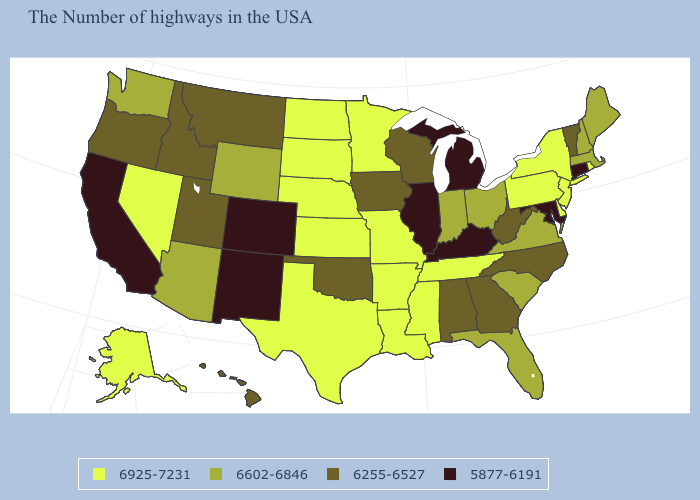What is the value of Delaware?
Be succinct. 6925-7231. Among the states that border Missouri , does Arkansas have the highest value?
Answer briefly. Yes. Which states have the highest value in the USA?
Quick response, please. Rhode Island, New York, New Jersey, Delaware, Pennsylvania, Tennessee, Mississippi, Louisiana, Missouri, Arkansas, Minnesota, Kansas, Nebraska, Texas, South Dakota, North Dakota, Nevada, Alaska. Does New Hampshire have a higher value than Mississippi?
Be succinct. No. Name the states that have a value in the range 6925-7231?
Write a very short answer. Rhode Island, New York, New Jersey, Delaware, Pennsylvania, Tennessee, Mississippi, Louisiana, Missouri, Arkansas, Minnesota, Kansas, Nebraska, Texas, South Dakota, North Dakota, Nevada, Alaska. What is the value of Ohio?
Answer briefly. 6602-6846. Does New Hampshire have a lower value than Michigan?
Short answer required. No. Which states have the lowest value in the South?
Quick response, please. Maryland, Kentucky. Does Wyoming have a higher value than Rhode Island?
Short answer required. No. Among the states that border Michigan , does Indiana have the highest value?
Be succinct. Yes. What is the value of Maryland?
Keep it brief. 5877-6191. Among the states that border Vermont , does New York have the lowest value?
Short answer required. No. Name the states that have a value in the range 6925-7231?
Short answer required. Rhode Island, New York, New Jersey, Delaware, Pennsylvania, Tennessee, Mississippi, Louisiana, Missouri, Arkansas, Minnesota, Kansas, Nebraska, Texas, South Dakota, North Dakota, Nevada, Alaska. What is the value of Utah?
Give a very brief answer. 6255-6527. Name the states that have a value in the range 6602-6846?
Give a very brief answer. Maine, Massachusetts, New Hampshire, Virginia, South Carolina, Ohio, Florida, Indiana, Wyoming, Arizona, Washington. 